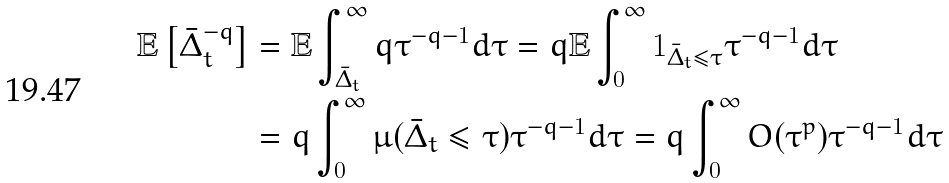<formula> <loc_0><loc_0><loc_500><loc_500>\mathbb { E } \left [ \bar { \Delta } _ { t } ^ { - q } \right ] & = \mathbb { E } \int _ { \bar { \Delta } _ { t } } ^ { \infty } q \tau ^ { - q - 1 } d \tau = q \mathbb { E } \int _ { 0 } ^ { \infty } 1 _ { \bar { \Delta } _ { t } \leq \tau } \tau ^ { - q - 1 } d \tau \\ & = q \int _ { 0 } ^ { \infty } \mu ( \bar { \Delta } _ { t } \leq \tau ) \tau ^ { - q - 1 } d \tau = q \int _ { 0 } ^ { \infty } O ( \tau ^ { p } ) \tau ^ { - q - 1 } d \tau</formula> 